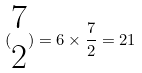Convert formula to latex. <formula><loc_0><loc_0><loc_500><loc_500>( \begin{matrix} 7 \\ 2 \end{matrix} ) = 6 \times \frac { 7 } { 2 } = 2 1</formula> 